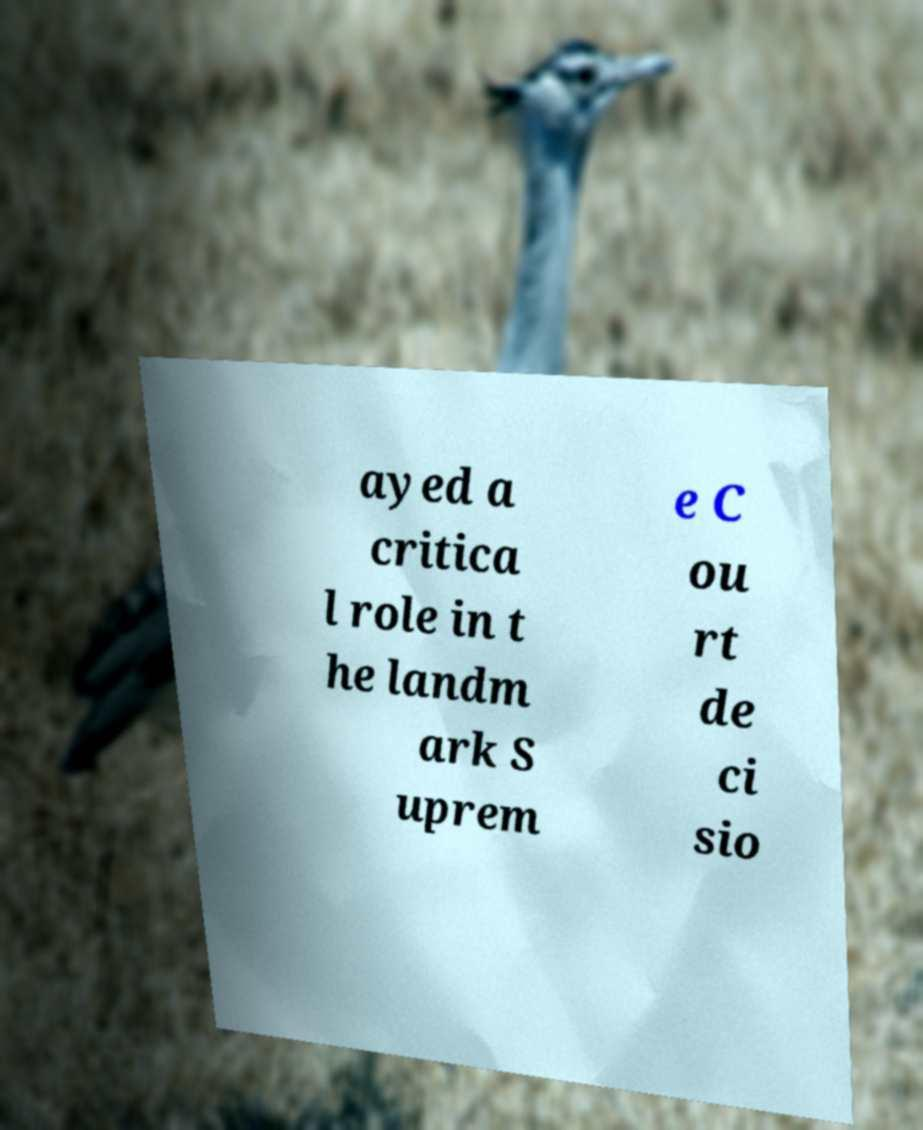Can you accurately transcribe the text from the provided image for me? ayed a critica l role in t he landm ark S uprem e C ou rt de ci sio 